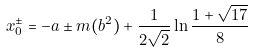<formula> <loc_0><loc_0><loc_500><loc_500>x _ { 0 } ^ { \pm } = - a \pm m ( b ^ { 2 } ) + \frac { 1 } { 2 \sqrt { 2 } } \ln \frac { 1 + \sqrt { 1 7 } } { 8 }</formula> 